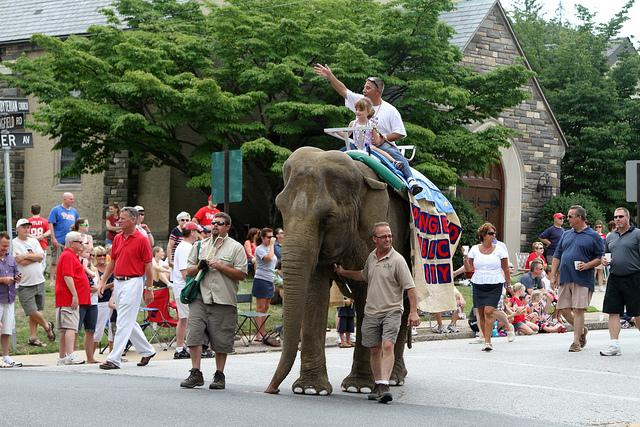What is the long fabric item hanging down the elephant's side? Please explain your reasoning. banner. The long fabric item on the side of the elephant contains a set of letters and words.   when these words are put together and displayed for others to see, it most likely part of a banner. 